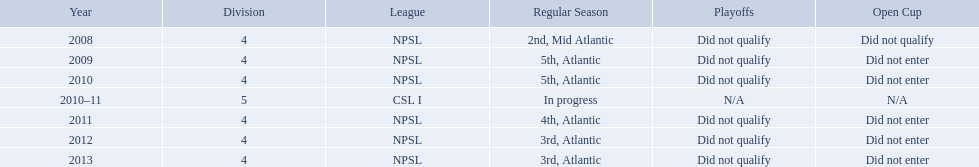What are all of the leagues? NPSL, NPSL, NPSL, CSL I, NPSL, NPSL, NPSL. Which league was played in the least? CSL I. Could you parse the entire table as a dict? {'header': ['Year', 'Division', 'League', 'Regular Season', 'Playoffs', 'Open Cup'], 'rows': [['2008', '4', 'NPSL', '2nd, Mid Atlantic', 'Did not qualify', 'Did not qualify'], ['2009', '4', 'NPSL', '5th, Atlantic', 'Did not qualify', 'Did not enter'], ['2010', '4', 'NPSL', '5th, Atlantic', 'Did not qualify', 'Did not enter'], ['2010–11', '5', 'CSL I', 'In progress', 'N/A', 'N/A'], ['2011', '4', 'NPSL', '4th, Atlantic', 'Did not qualify', 'Did not enter'], ['2012', '4', 'NPSL', '3rd, Atlantic', 'Did not qualify', 'Did not enter'], ['2013', '4', 'NPSL', '3rd, Atlantic', 'Did not qualify', 'Did not enter']]} What are all the different leagues? NPSL, NPSL, NPSL, CSL I, NPSL, NPSL, NPSL. Which league experienced the lowest participation? CSL I. What are all of the associations? NPSL, NPSL, NPSL, CSL I, NPSL, NPSL, NPSL. Which association had the least play? CSL I. What are the appellations of the leagues? NPSL, CSL I. In which league other than npsl did the ny soccer team perform? CSL I. What are the designations of the leagues? NPSL, CSL I. In which league apart from npsl did the ny soccer team compete? CSL I. 